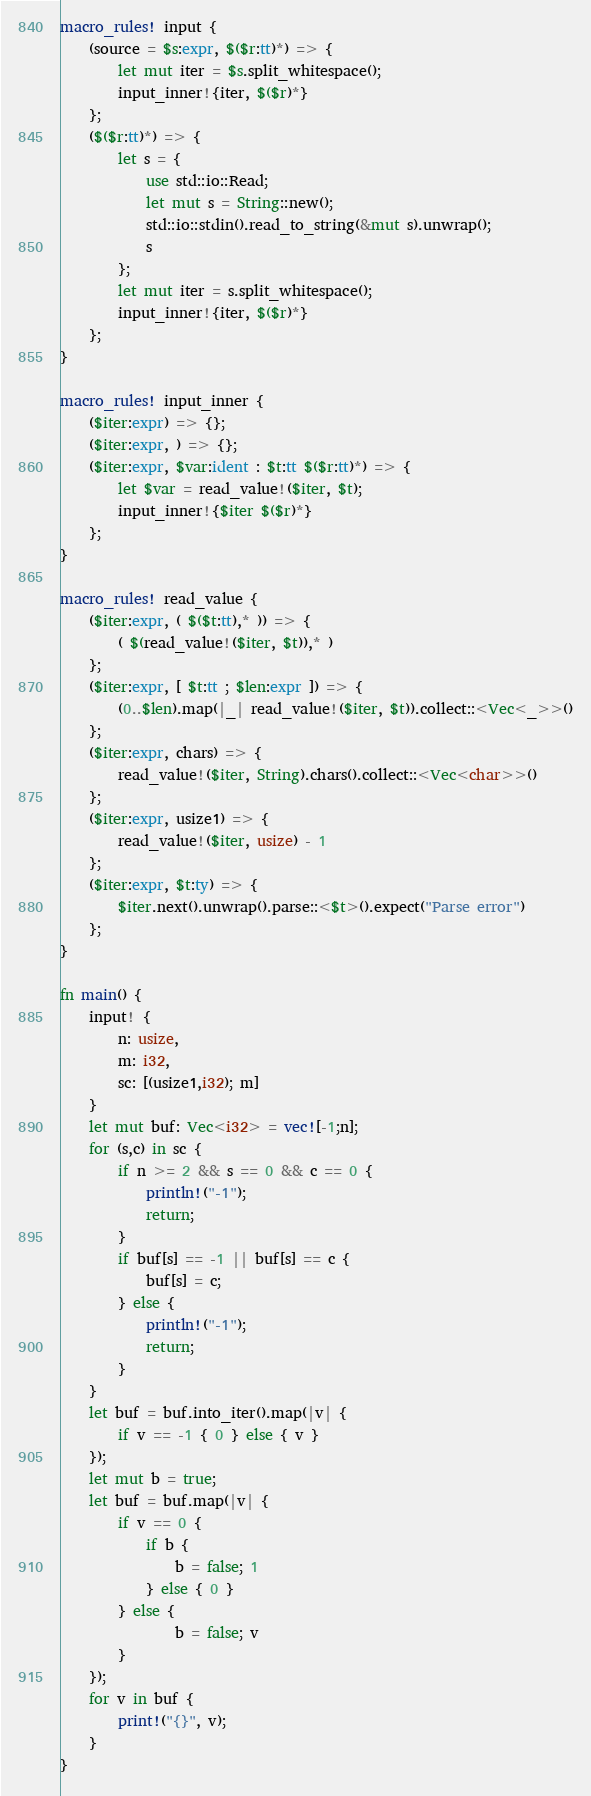Convert code to text. <code><loc_0><loc_0><loc_500><loc_500><_Rust_>macro_rules! input {
    (source = $s:expr, $($r:tt)*) => {
        let mut iter = $s.split_whitespace();
        input_inner!{iter, $($r)*}
    };
    ($($r:tt)*) => {
        let s = {
            use std::io::Read;
            let mut s = String::new();
            std::io::stdin().read_to_string(&mut s).unwrap();
            s
        };
        let mut iter = s.split_whitespace();
        input_inner!{iter, $($r)*}
    };
}

macro_rules! input_inner {
    ($iter:expr) => {};
    ($iter:expr, ) => {};
    ($iter:expr, $var:ident : $t:tt $($r:tt)*) => {
        let $var = read_value!($iter, $t);
        input_inner!{$iter $($r)*}
    };
}

macro_rules! read_value {
    ($iter:expr, ( $($t:tt),* )) => {
        ( $(read_value!($iter, $t)),* )
    };
    ($iter:expr, [ $t:tt ; $len:expr ]) => {
        (0..$len).map(|_| read_value!($iter, $t)).collect::<Vec<_>>()
    };
    ($iter:expr, chars) => {
        read_value!($iter, String).chars().collect::<Vec<char>>()
    };
    ($iter:expr, usize1) => {
        read_value!($iter, usize) - 1
    };
    ($iter:expr, $t:ty) => {
        $iter.next().unwrap().parse::<$t>().expect("Parse error")
    };
}

fn main() {
    input! {
        n: usize,
        m: i32,
        sc: [(usize1,i32); m]
    }
    let mut buf: Vec<i32> = vec![-1;n];
    for (s,c) in sc {
        if n >= 2 && s == 0 && c == 0 {
            println!("-1");
            return;
        }
        if buf[s] == -1 || buf[s] == c {
            buf[s] = c;
        } else {
            println!("-1");
            return;
        }
    }
    let buf = buf.into_iter().map(|v| {
        if v == -1 { 0 } else { v }
    });
    let mut b = true;
    let buf = buf.map(|v| {
        if v == 0 {
            if b {
                b = false; 1
            } else { 0 }
        } else {
                b = false; v
        }
    });
    for v in buf {
        print!("{}", v);
    }
}</code> 